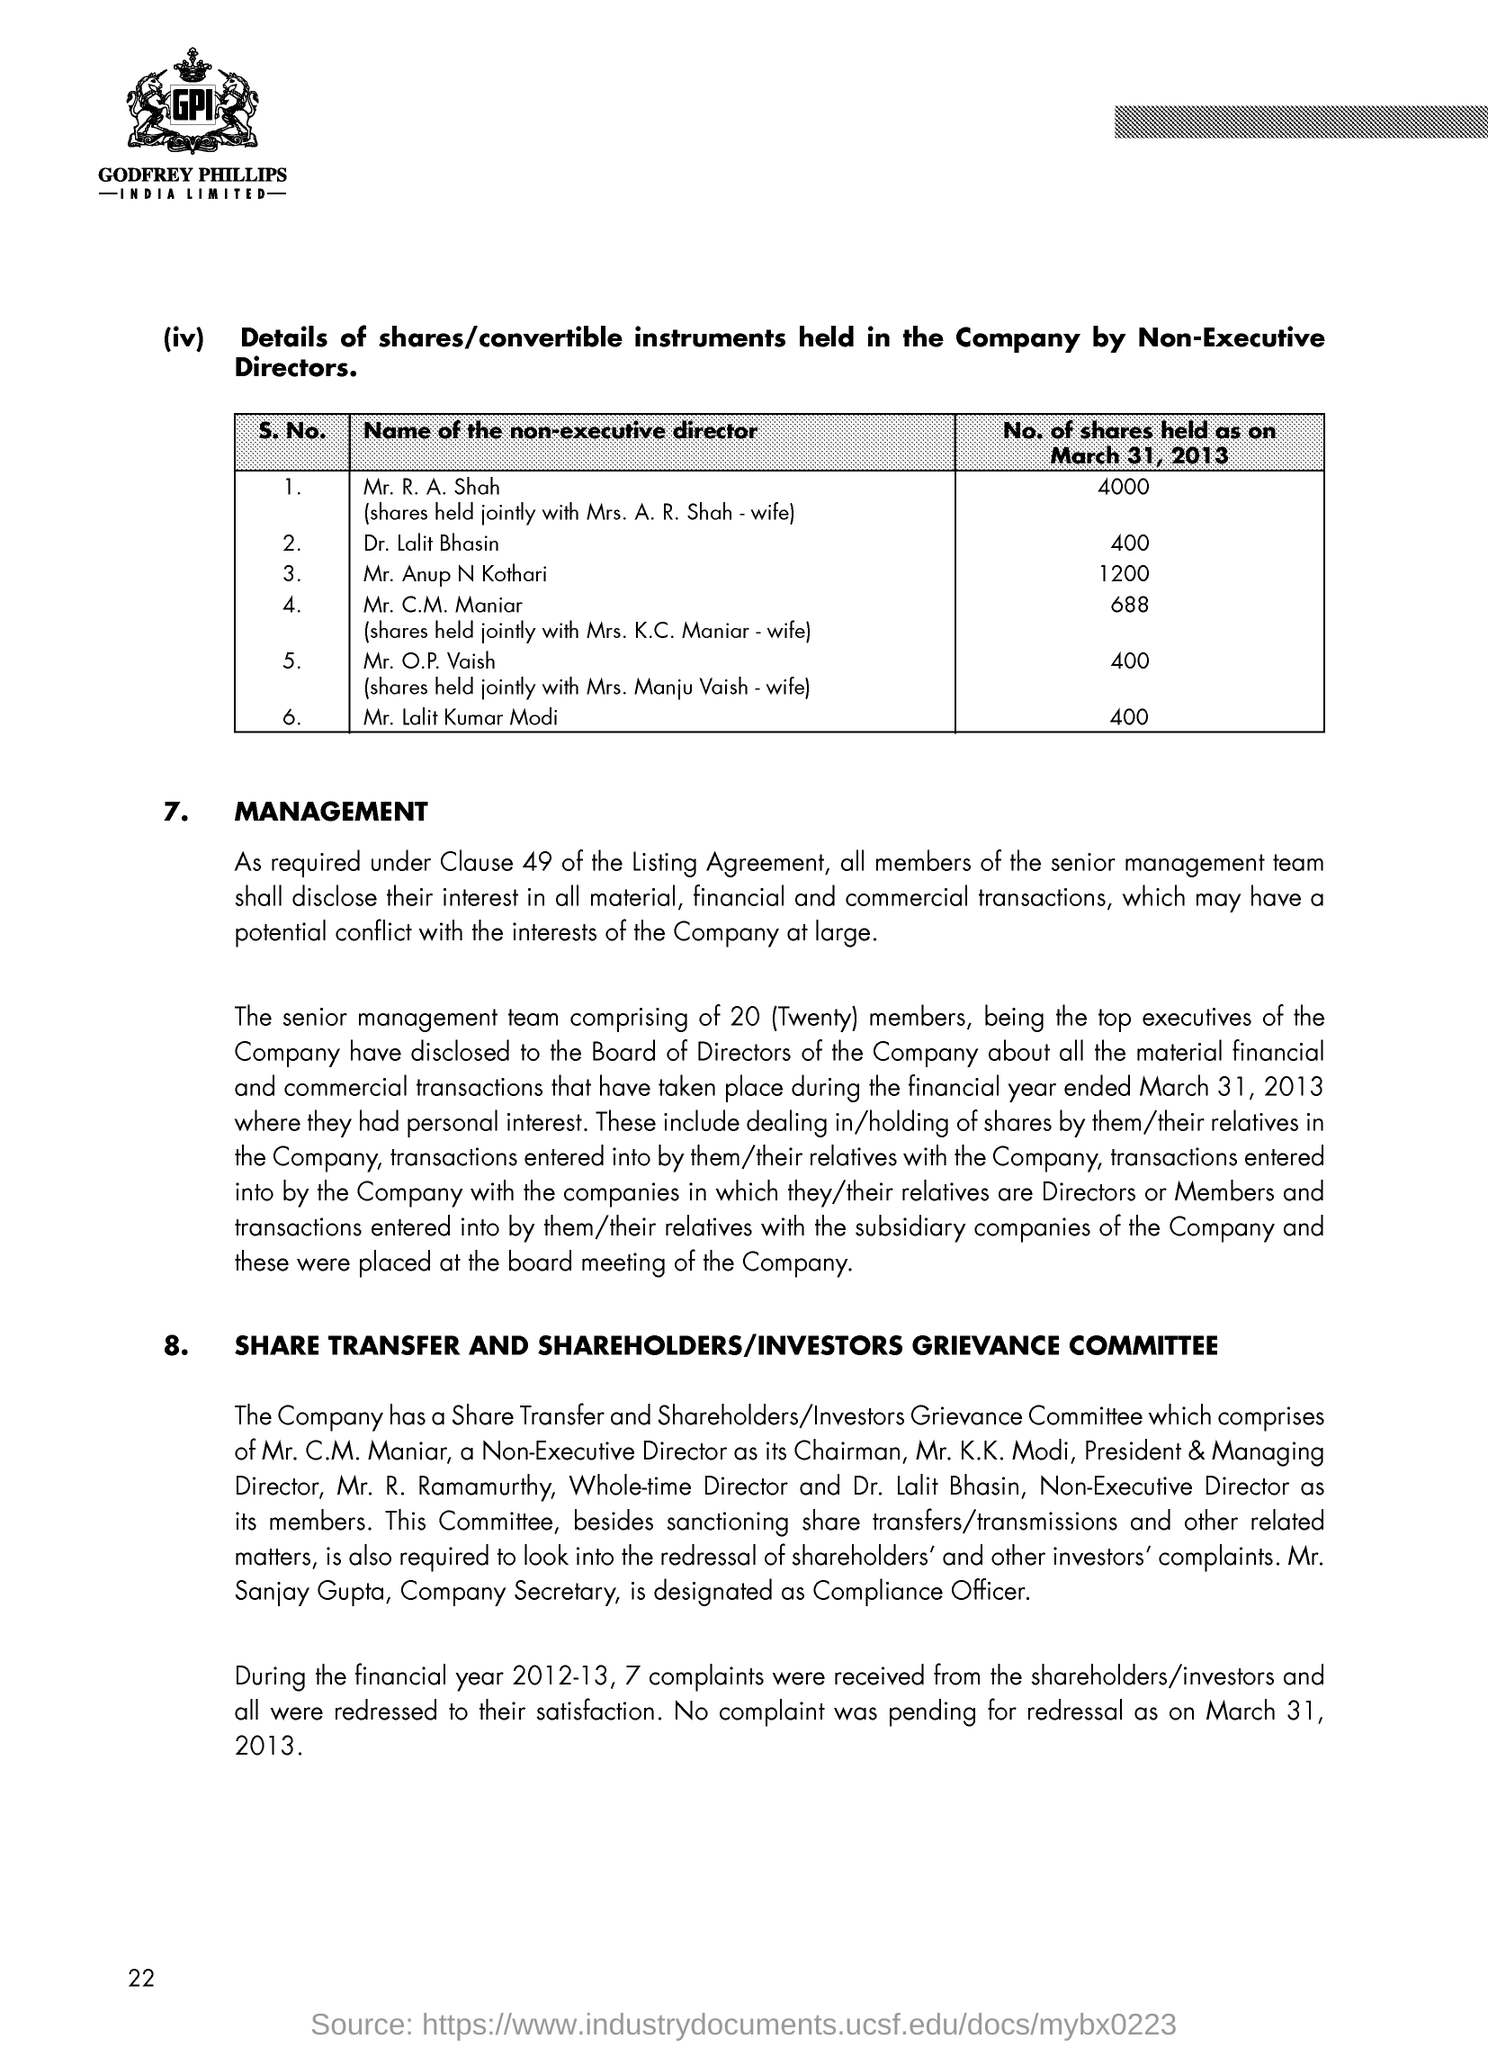How much share do Mr & Mrs. Shah hold in the company?
Your response must be concise. 4000. How much share do Mr & Mrs. Maniar hold in the company?
Offer a terse response. 688. How much share do Mr & Mrs. Vaish hold in the company?
Your answer should be compact. 400. How much share do Mr. Lalit kumar Modi hold in the company?
Offer a very short reply. 400. How much share do Mr. Anup N Kothari hold in the company?
Offer a terse response. 1200. How much share do Dr. Lalit Bhasin hold in the company?
Keep it short and to the point. 400. 